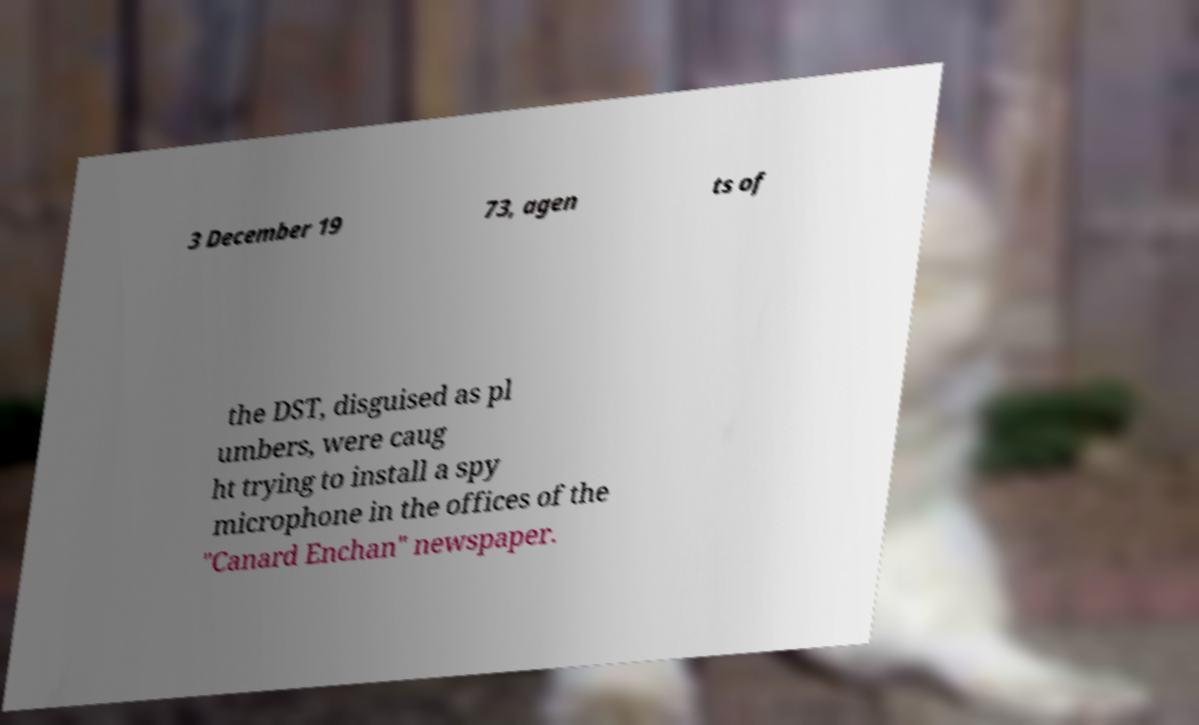Can you accurately transcribe the text from the provided image for me? 3 December 19 73, agen ts of the DST, disguised as pl umbers, were caug ht trying to install a spy microphone in the offices of the "Canard Enchan" newspaper. 